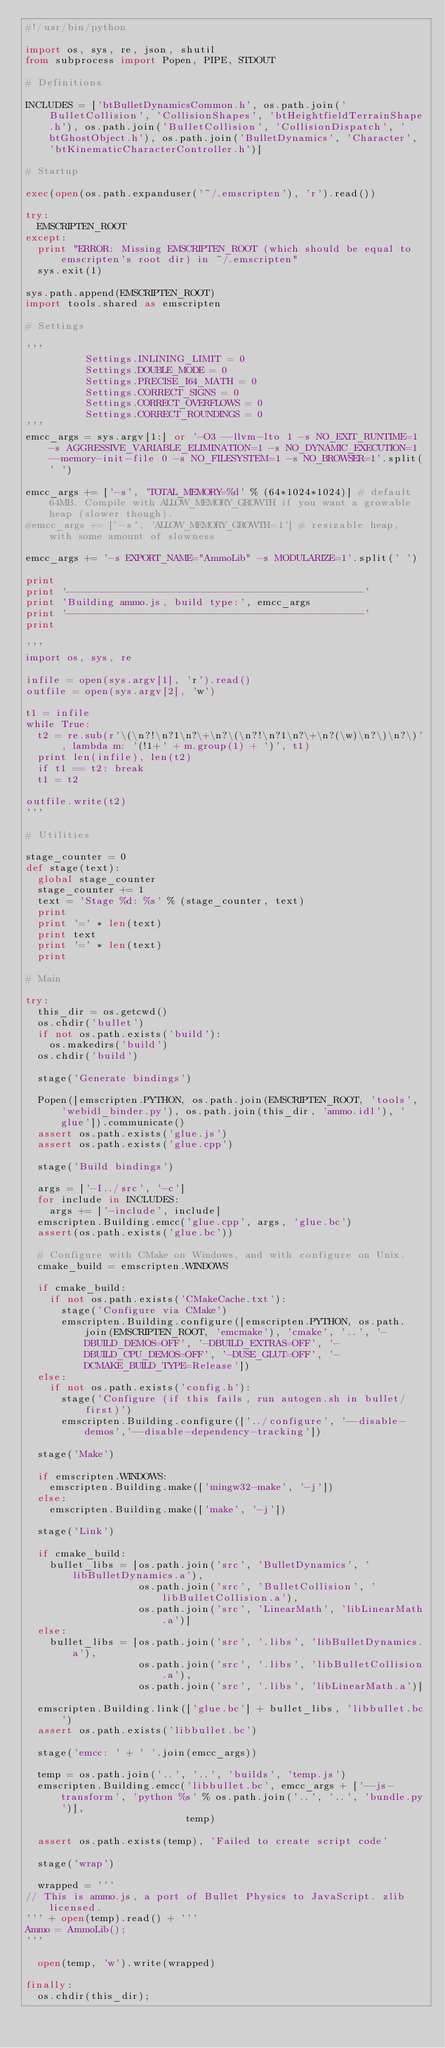Convert code to text. <code><loc_0><loc_0><loc_500><loc_500><_Python_>#!/usr/bin/python

import os, sys, re, json, shutil
from subprocess import Popen, PIPE, STDOUT

# Definitions

INCLUDES = ['btBulletDynamicsCommon.h', os.path.join('BulletCollision', 'CollisionShapes', 'btHeightfieldTerrainShape.h'), os.path.join('BulletCollision', 'CollisionDispatch', 'btGhostObject.h'), os.path.join('BulletDynamics', 'Character', 'btKinematicCharacterController.h')]

# Startup

exec(open(os.path.expanduser('~/.emscripten'), 'r').read())

try:
  EMSCRIPTEN_ROOT
except:
  print "ERROR: Missing EMSCRIPTEN_ROOT (which should be equal to emscripten's root dir) in ~/.emscripten"
  sys.exit(1)

sys.path.append(EMSCRIPTEN_ROOT)
import tools.shared as emscripten

# Settings

'''
          Settings.INLINING_LIMIT = 0
          Settings.DOUBLE_MODE = 0
          Settings.PRECISE_I64_MATH = 0
          Settings.CORRECT_SIGNS = 0
          Settings.CORRECT_OVERFLOWS = 0
          Settings.CORRECT_ROUNDINGS = 0
'''
emcc_args = sys.argv[1:] or '-O3 --llvm-lto 1 -s NO_EXIT_RUNTIME=1 -s AGGRESSIVE_VARIABLE_ELIMINATION=1 -s NO_DYNAMIC_EXECUTION=1 --memory-init-file 0 -s NO_FILESYSTEM=1 -s NO_BROWSER=1'.split(' ')

emcc_args += ['-s', 'TOTAL_MEMORY=%d' % (64*1024*1024)] # default 64MB. Compile with ALLOW_MEMORY_GROWTH if you want a growable heap (slower though).
#emcc_args += ['-s', 'ALLOW_MEMORY_GROWTH=1'] # resizable heap, with some amount of slowness

emcc_args += '-s EXPORT_NAME="AmmoLib" -s MODULARIZE=1'.split(' ')

print
print '--------------------------------------------------'
print 'Building ammo.js, build type:', emcc_args
print '--------------------------------------------------'
print

'''
import os, sys, re

infile = open(sys.argv[1], 'r').read()
outfile = open(sys.argv[2], 'w')

t1 = infile
while True:
  t2 = re.sub(r'\(\n?!\n?1\n?\+\n?\(\n?!\n?1\n?\+\n?(\w)\n?\)\n?\)', lambda m: '(!1+' + m.group(1) + ')', t1)
  print len(infile), len(t2)
  if t1 == t2: break
  t1 = t2

outfile.write(t2)
'''

# Utilities

stage_counter = 0
def stage(text):
  global stage_counter
  stage_counter += 1
  text = 'Stage %d: %s' % (stage_counter, text)
  print
  print '=' * len(text)
  print text
  print '=' * len(text)
  print

# Main

try:
  this_dir = os.getcwd()
  os.chdir('bullet')
  if not os.path.exists('build'):
    os.makedirs('build')
  os.chdir('build')

  stage('Generate bindings')

  Popen([emscripten.PYTHON, os.path.join(EMSCRIPTEN_ROOT, 'tools', 'webidl_binder.py'), os.path.join(this_dir, 'ammo.idl'), 'glue']).communicate()
  assert os.path.exists('glue.js')
  assert os.path.exists('glue.cpp')

  stage('Build bindings')

  args = ['-I../src', '-c']
  for include in INCLUDES:
    args += ['-include', include]
  emscripten.Building.emcc('glue.cpp', args, 'glue.bc')
  assert(os.path.exists('glue.bc'))

  # Configure with CMake on Windows, and with configure on Unix.
  cmake_build = emscripten.WINDOWS

  if cmake_build:
    if not os.path.exists('CMakeCache.txt'):
      stage('Configure via CMake')
      emscripten.Building.configure([emscripten.PYTHON, os.path.join(EMSCRIPTEN_ROOT, 'emcmake'), 'cmake', '..', '-DBUILD_DEMOS=OFF', '-DBUILD_EXTRAS=OFF', '-DBUILD_CPU_DEMOS=OFF', '-DUSE_GLUT=OFF', '-DCMAKE_BUILD_TYPE=Release'])
  else:
    if not os.path.exists('config.h'):
      stage('Configure (if this fails, run autogen.sh in bullet/ first)')
      emscripten.Building.configure(['../configure', '--disable-demos','--disable-dependency-tracking'])

  stage('Make')

  if emscripten.WINDOWS:
    emscripten.Building.make(['mingw32-make', '-j'])
  else:
    emscripten.Building.make(['make', '-j'])

  stage('Link')

  if cmake_build:
    bullet_libs = [os.path.join('src', 'BulletDynamics', 'libBulletDynamics.a'),
                   os.path.join('src', 'BulletCollision', 'libBulletCollision.a'),
                   os.path.join('src', 'LinearMath', 'libLinearMath.a')]
  else:
    bullet_libs = [os.path.join('src', '.libs', 'libBulletDynamics.a'),
                   os.path.join('src', '.libs', 'libBulletCollision.a'),
                   os.path.join('src', '.libs', 'libLinearMath.a')]

  emscripten.Building.link(['glue.bc'] + bullet_libs, 'libbullet.bc')
  assert os.path.exists('libbullet.bc')

  stage('emcc: ' + ' '.join(emcc_args))

  temp = os.path.join('..', '..', 'builds', 'temp.js')
  emscripten.Building.emcc('libbullet.bc', emcc_args + ['--js-transform', 'python %s' % os.path.join('..', '..', 'bundle.py')],
                           temp)

  assert os.path.exists(temp), 'Failed to create script code'

  stage('wrap')

  wrapped = '''
// This is ammo.js, a port of Bullet Physics to JavaScript. zlib licensed.
''' + open(temp).read() + '''
Ammo = AmmoLib();
'''

  open(temp, 'w').write(wrapped)

finally:
  os.chdir(this_dir);

</code> 